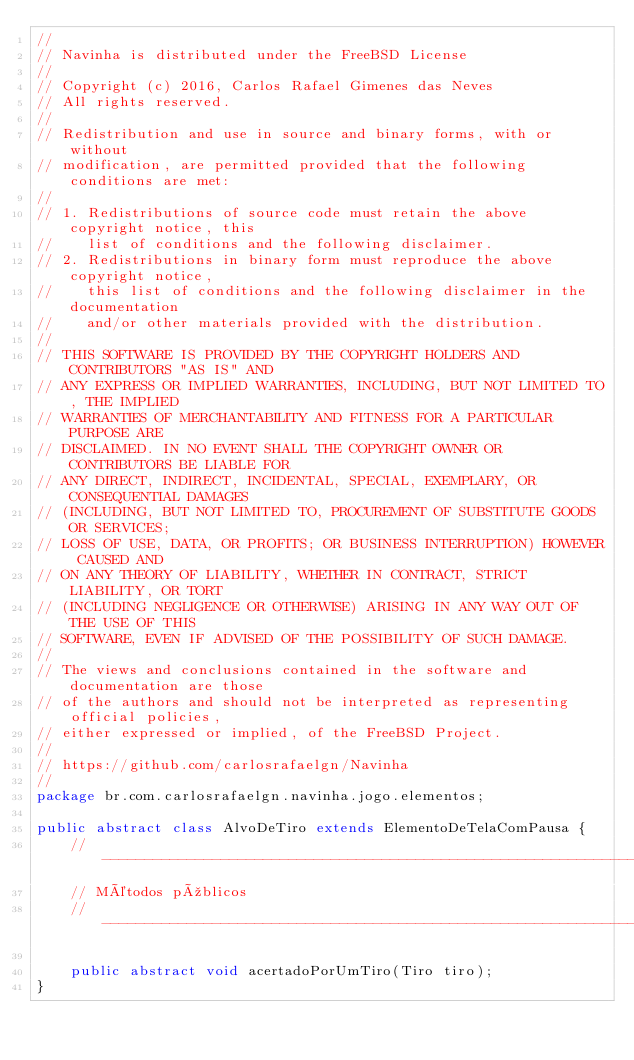<code> <loc_0><loc_0><loc_500><loc_500><_Java_>//
// Navinha is distributed under the FreeBSD License
//
// Copyright (c) 2016, Carlos Rafael Gimenes das Neves
// All rights reserved.
//
// Redistribution and use in source and binary forms, with or without
// modification, are permitted provided that the following conditions are met:
//
// 1. Redistributions of source code must retain the above copyright notice, this
//    list of conditions and the following disclaimer.
// 2. Redistributions in binary form must reproduce the above copyright notice,
//    this list of conditions and the following disclaimer in the documentation
//    and/or other materials provided with the distribution.
//
// THIS SOFTWARE IS PROVIDED BY THE COPYRIGHT HOLDERS AND CONTRIBUTORS "AS IS" AND
// ANY EXPRESS OR IMPLIED WARRANTIES, INCLUDING, BUT NOT LIMITED TO, THE IMPLIED
// WARRANTIES OF MERCHANTABILITY AND FITNESS FOR A PARTICULAR PURPOSE ARE
// DISCLAIMED. IN NO EVENT SHALL THE COPYRIGHT OWNER OR CONTRIBUTORS BE LIABLE FOR
// ANY DIRECT, INDIRECT, INCIDENTAL, SPECIAL, EXEMPLARY, OR CONSEQUENTIAL DAMAGES
// (INCLUDING, BUT NOT LIMITED TO, PROCUREMENT OF SUBSTITUTE GOODS OR SERVICES;
// LOSS OF USE, DATA, OR PROFITS; OR BUSINESS INTERRUPTION) HOWEVER CAUSED AND
// ON ANY THEORY OF LIABILITY, WHETHER IN CONTRACT, STRICT LIABILITY, OR TORT
// (INCLUDING NEGLIGENCE OR OTHERWISE) ARISING IN ANY WAY OUT OF THE USE OF THIS
// SOFTWARE, EVEN IF ADVISED OF THE POSSIBILITY OF SUCH DAMAGE.
//
// The views and conclusions contained in the software and documentation are those
// of the authors and should not be interpreted as representing official policies,
// either expressed or implied, of the FreeBSD Project.
//
// https://github.com/carlosrafaelgn/Navinha
//
package br.com.carlosrafaelgn.navinha.jogo.elementos;

public abstract class AlvoDeTiro extends ElementoDeTelaComPausa {
	//----------------------------------------------------------------------------------------------
	// Métodos públicos
	//----------------------------------------------------------------------------------------------

	public abstract void acertadoPorUmTiro(Tiro tiro);
}
</code> 